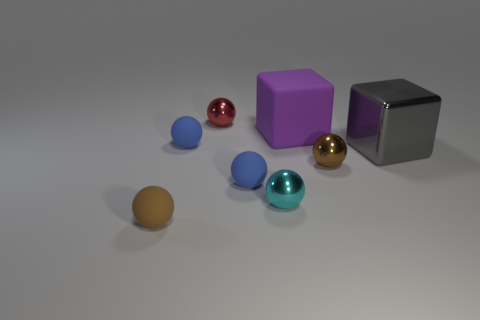How would you describe the overall composition and the arrangement of colors in this scene? The composition is minimalist with a balanced arrangement of objects. The colors are strategically placed to create a visually harmonious scene, with the cool blue and teal spheres complementing the warmer tones of the gold and brown spheres. The purple and gray matte cubes add a contrasting shape and texture to the roundness of the spheres. 